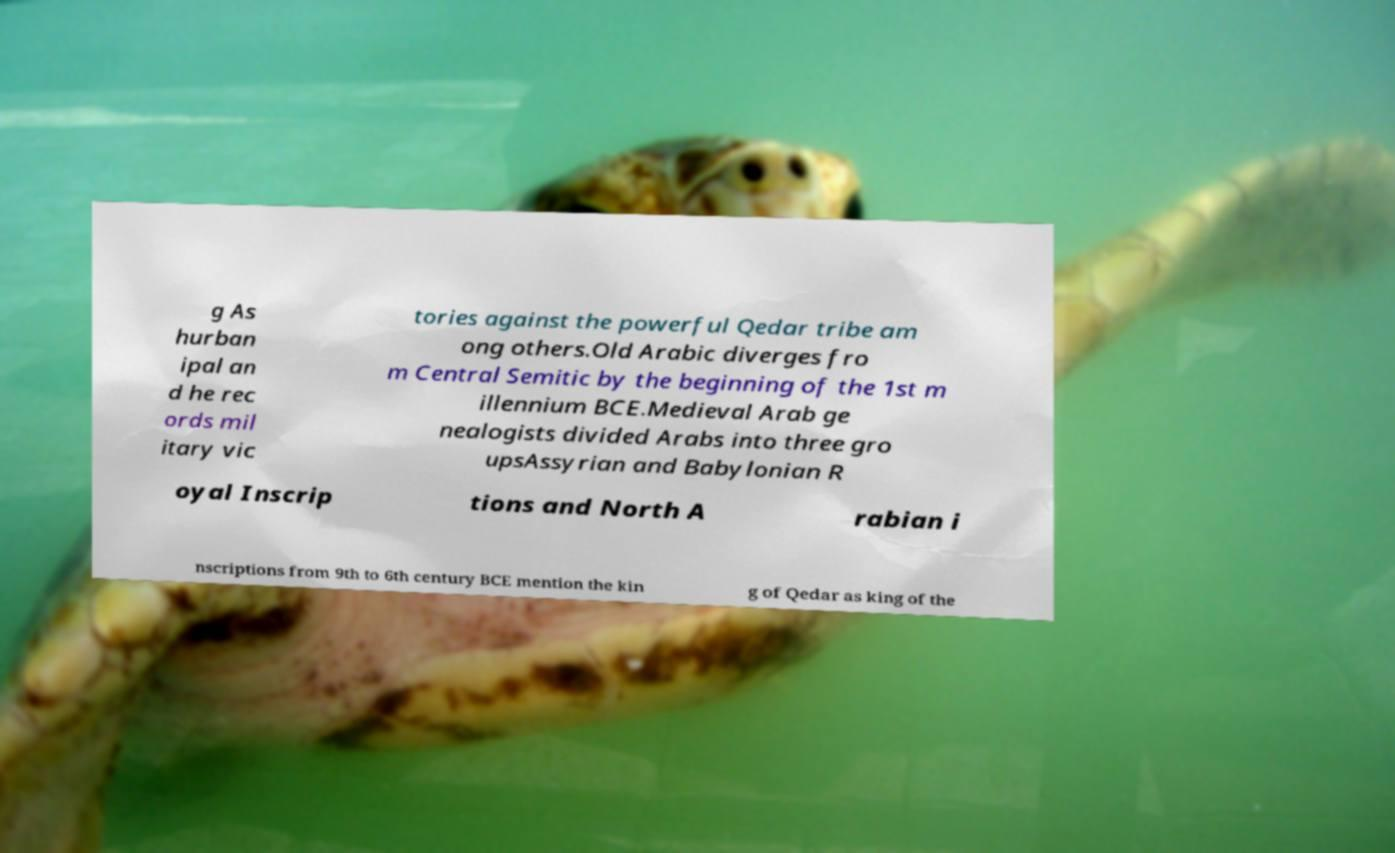Can you accurately transcribe the text from the provided image for me? g As hurban ipal an d he rec ords mil itary vic tories against the powerful Qedar tribe am ong others.Old Arabic diverges fro m Central Semitic by the beginning of the 1st m illennium BCE.Medieval Arab ge nealogists divided Arabs into three gro upsAssyrian and Babylonian R oyal Inscrip tions and North A rabian i nscriptions from 9th to 6th century BCE mention the kin g of Qedar as king of the 